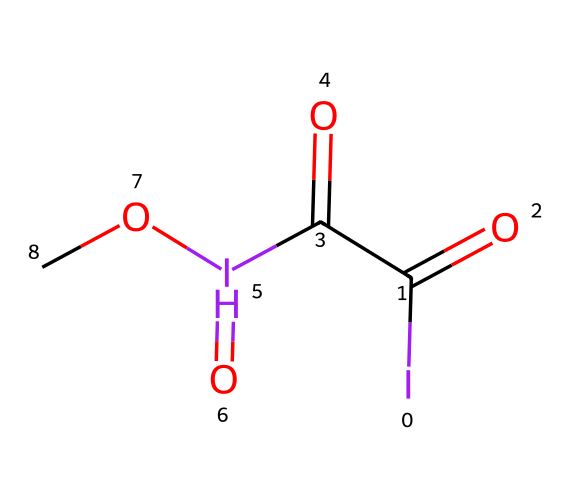What is the central atom in this hypervalent compound? The central atom in this compound is iodine, which is essential for hypervalency. From the SMILES representation, we can see the presence of iodine (I) as the main atom in the structure, surrounded by various functional groups.
Answer: iodine How many oxygen atoms are present in the compound? In the provided SMILES, we see four occurrences of oxygen atoms represented as 'O'. These appear in different functional groups like the carbonyl (C=O) and ether (–O–) connections.
Answer: four Does this compound have any double bonds? Yes, the structure includes double bonds, specifically carbonyl groups (C=O). Looking closely at the SMILES, we notice that carbon atoms are double-bonded to oxygen, indicating the presence of such bonds.
Answer: yes What type of functional groups are present in this compound? The compound contains carbonyl (C=O) and ether (–O–) functional groups. By analyzing the SMILES, we identify these specific groups based on their bonding and connectivity with the central atoms.
Answer: carbonyl and ether How many total atoms are in the compound? To calculate the total number of atoms, we sum the distinct types present in the SMILES: 2 iodine, 4 carbon, 4 oxygen, giving us a total of 10 atoms. Reviewing the SMILES helps to enumerate each atom systematically.
Answer: ten What is the oxidation state of iodine in this compound? The oxidation state of iodine can be determined by analyzing the number of bonds it forms with other atoms. Here, iodine has a coordination number of 5, indicating a +5 oxidation state due to its bonding with one carbon (C) and three oxygen atoms (O).
Answer: plus five Is this compound likely to be a good catalyst for resin curing? Yes, due to its hypervalent nature and the presence of iodine, it can facilitate reactions typical for resin curing processes. The structural features suggest it can effectively stabilize transition states during polymerization.
Answer: yes 